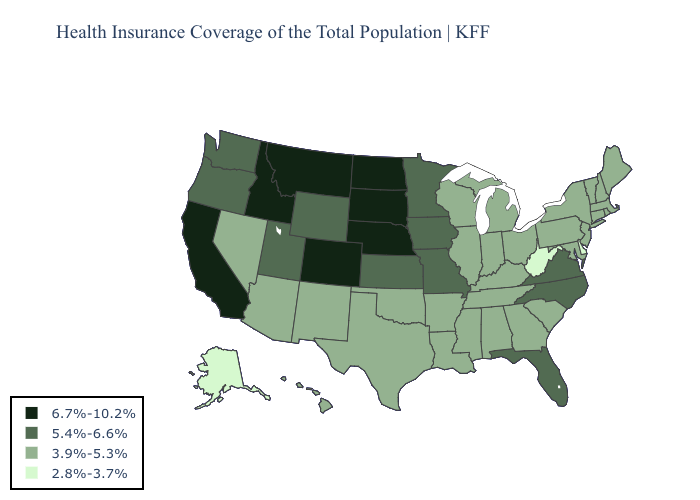Among the states that border South Dakota , which have the lowest value?
Short answer required. Iowa, Minnesota, Wyoming. Does California have the highest value in the USA?
Short answer required. Yes. Does Wyoming have a higher value than Washington?
Keep it brief. No. Which states have the highest value in the USA?
Concise answer only. California, Colorado, Idaho, Montana, Nebraska, North Dakota, South Dakota. Does Illinois have the same value as Michigan?
Answer briefly. Yes. Does Massachusetts have the lowest value in the USA?
Be succinct. No. What is the highest value in states that border Arizona?
Be succinct. 6.7%-10.2%. Does Vermont have the highest value in the USA?
Keep it brief. No. Which states have the highest value in the USA?
Give a very brief answer. California, Colorado, Idaho, Montana, Nebraska, North Dakota, South Dakota. What is the value of Alaska?
Write a very short answer. 2.8%-3.7%. Is the legend a continuous bar?
Short answer required. No. Name the states that have a value in the range 6.7%-10.2%?
Give a very brief answer. California, Colorado, Idaho, Montana, Nebraska, North Dakota, South Dakota. What is the highest value in the Northeast ?
Be succinct. 3.9%-5.3%. Which states have the highest value in the USA?
Be succinct. California, Colorado, Idaho, Montana, Nebraska, North Dakota, South Dakota. What is the value of Maryland?
Concise answer only. 3.9%-5.3%. 